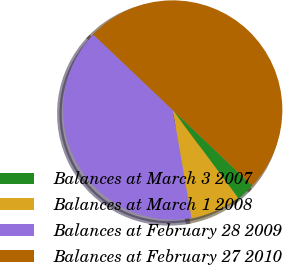<chart> <loc_0><loc_0><loc_500><loc_500><pie_chart><fcel>Balances at March 3 2007<fcel>Balances at March 1 2008<fcel>Balances at February 28 2009<fcel>Balances at February 27 2010<nl><fcel>2.72%<fcel>7.45%<fcel>39.83%<fcel>50.0%<nl></chart> 